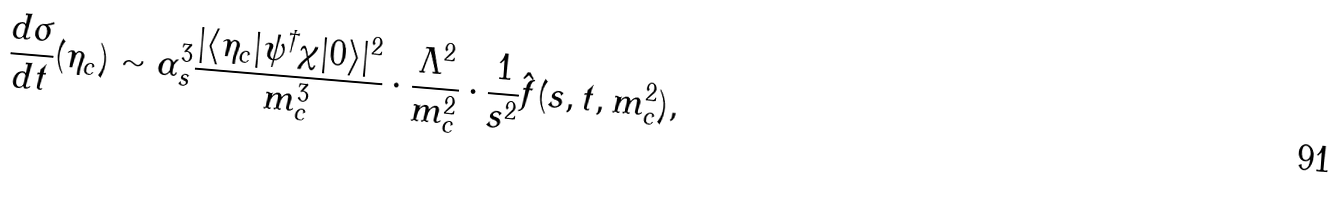<formula> <loc_0><loc_0><loc_500><loc_500>\frac { d \sigma } { d t } ( \eta _ { c } ) \sim \alpha _ { s } ^ { 3 } \frac { | \langle \eta _ { c } | \psi ^ { \dagger } \chi | 0 \rangle | ^ { 2 } } { m _ { c } ^ { 3 } } \cdot \frac { \Lambda ^ { 2 } } { m _ { c } ^ { 2 } } \cdot \frac { 1 } { s ^ { 2 } } \hat { f } ( s , t , m _ { c } ^ { 2 } ) ,</formula> 